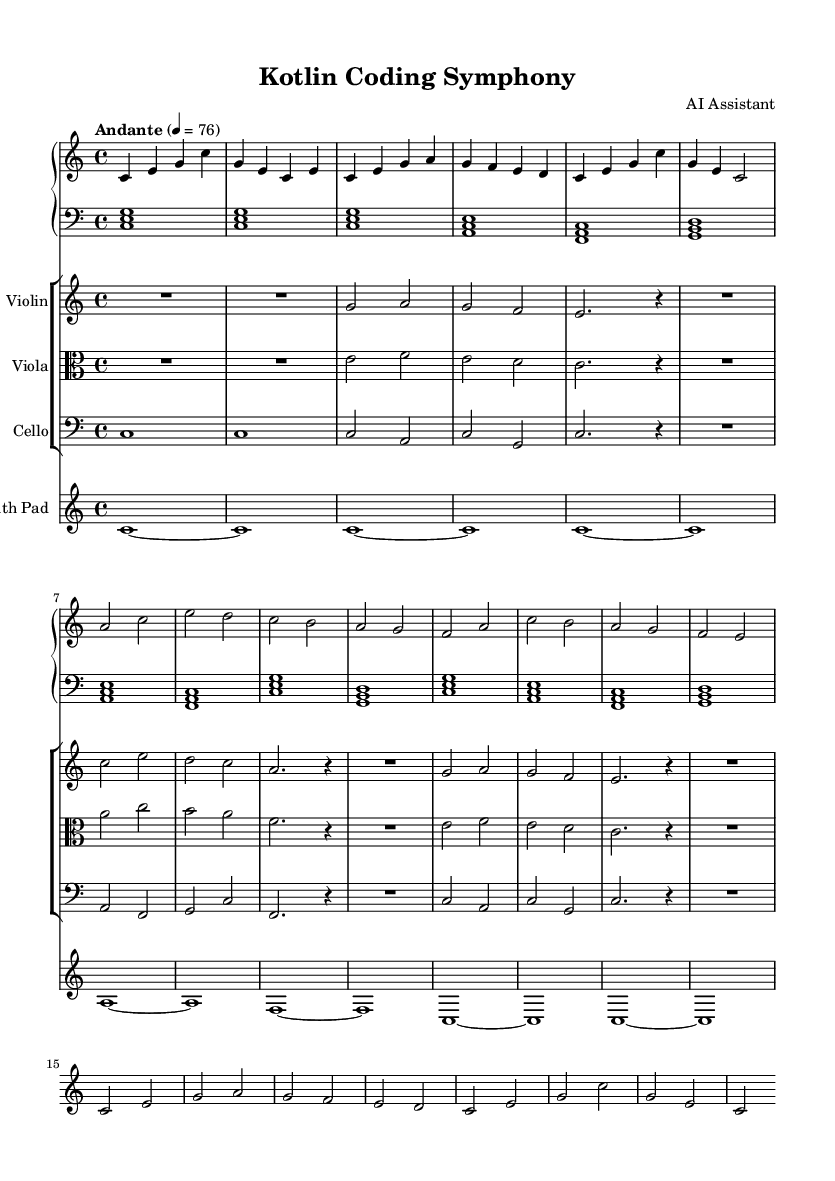What is the key signature of this music? The key signature is found at the beginning of the sheet music. It shows no sharps or flats, indicating that the piece is in C major.
Answer: C major What is the time signature of the piece? The time signature appears at the beginning of the music and is represented as 4/4, meaning there are four beats in each measure and the quarter note gets one beat.
Answer: 4/4 What is the tempo marking given for the symphony? The tempo marking is indicated at the start of the sheet music. It reads "Andante" with a metronome marking of 76, suggesting a moderate walking pace.
Answer: Andante, 76 How many measures are in the piano right hand part? To find the number of measures, we count the phrases notated in the piano right hand from the beginning to the end. There are 5 measures in total.
Answer: 5 measures Which instrument plays the melody in this piece? The melody can be identified by examining the staff lines primarily responsible for the higher pitches; in this case, the piano right hand and the violin are the main melody carriers. The piano right hand contains the primary melodic line.
Answer: Piano right hand Which sections of the symphony are repeated? Examining the structure, we can observe that the section labeled A appears twice in succession within the piece, indicating a repeated section.
Answer: Section A 